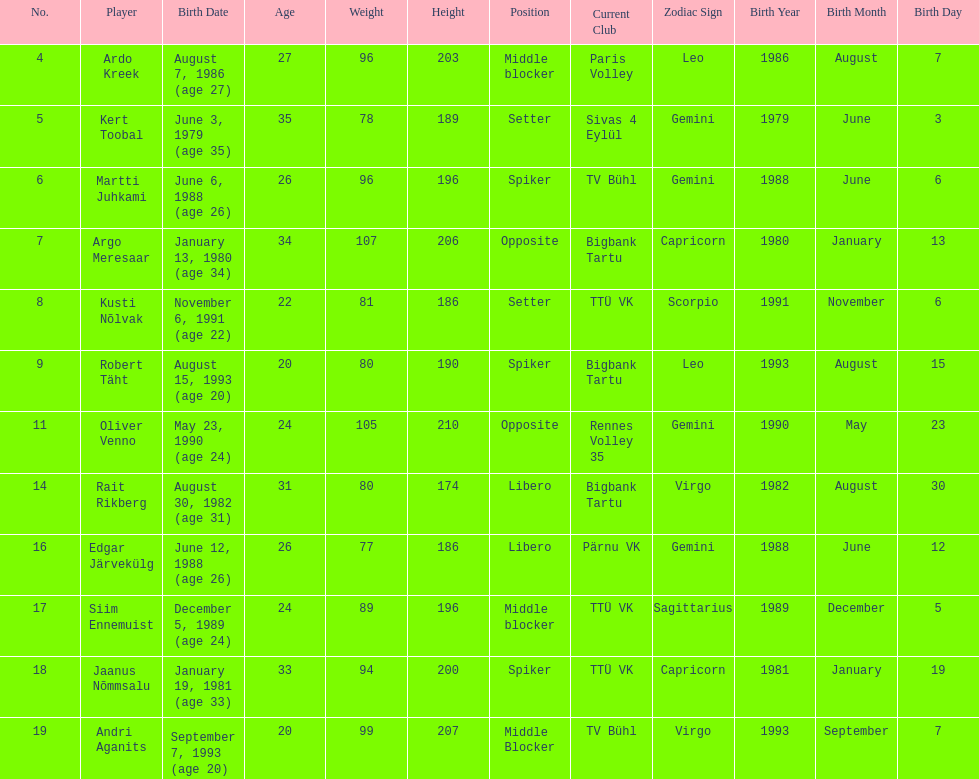Who are all of the players? Ardo Kreek, Kert Toobal, Martti Juhkami, Argo Meresaar, Kusti Nõlvak, Robert Täht, Oliver Venno, Rait Rikberg, Edgar Järvekülg, Siim Ennemuist, Jaanus Nõmmsalu, Andri Aganits. How tall are they? 203, 189, 196, 206, 186, 190, 210, 174, 186, 196, 200, 207. And which player is tallest? Oliver Venno. 